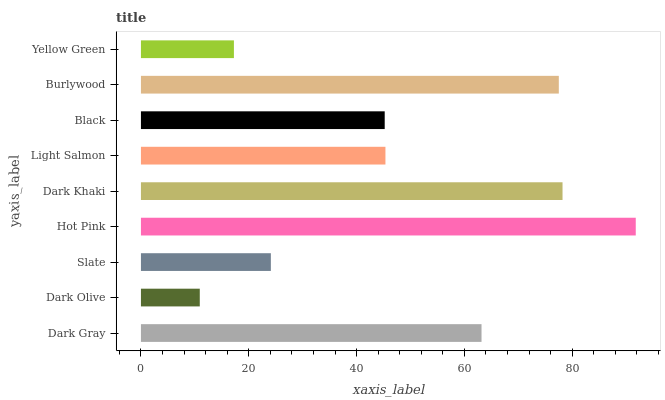Is Dark Olive the minimum?
Answer yes or no. Yes. Is Hot Pink the maximum?
Answer yes or no. Yes. Is Slate the minimum?
Answer yes or no. No. Is Slate the maximum?
Answer yes or no. No. Is Slate greater than Dark Olive?
Answer yes or no. Yes. Is Dark Olive less than Slate?
Answer yes or no. Yes. Is Dark Olive greater than Slate?
Answer yes or no. No. Is Slate less than Dark Olive?
Answer yes or no. No. Is Light Salmon the high median?
Answer yes or no. Yes. Is Light Salmon the low median?
Answer yes or no. Yes. Is Dark Olive the high median?
Answer yes or no. No. Is Dark Khaki the low median?
Answer yes or no. No. 